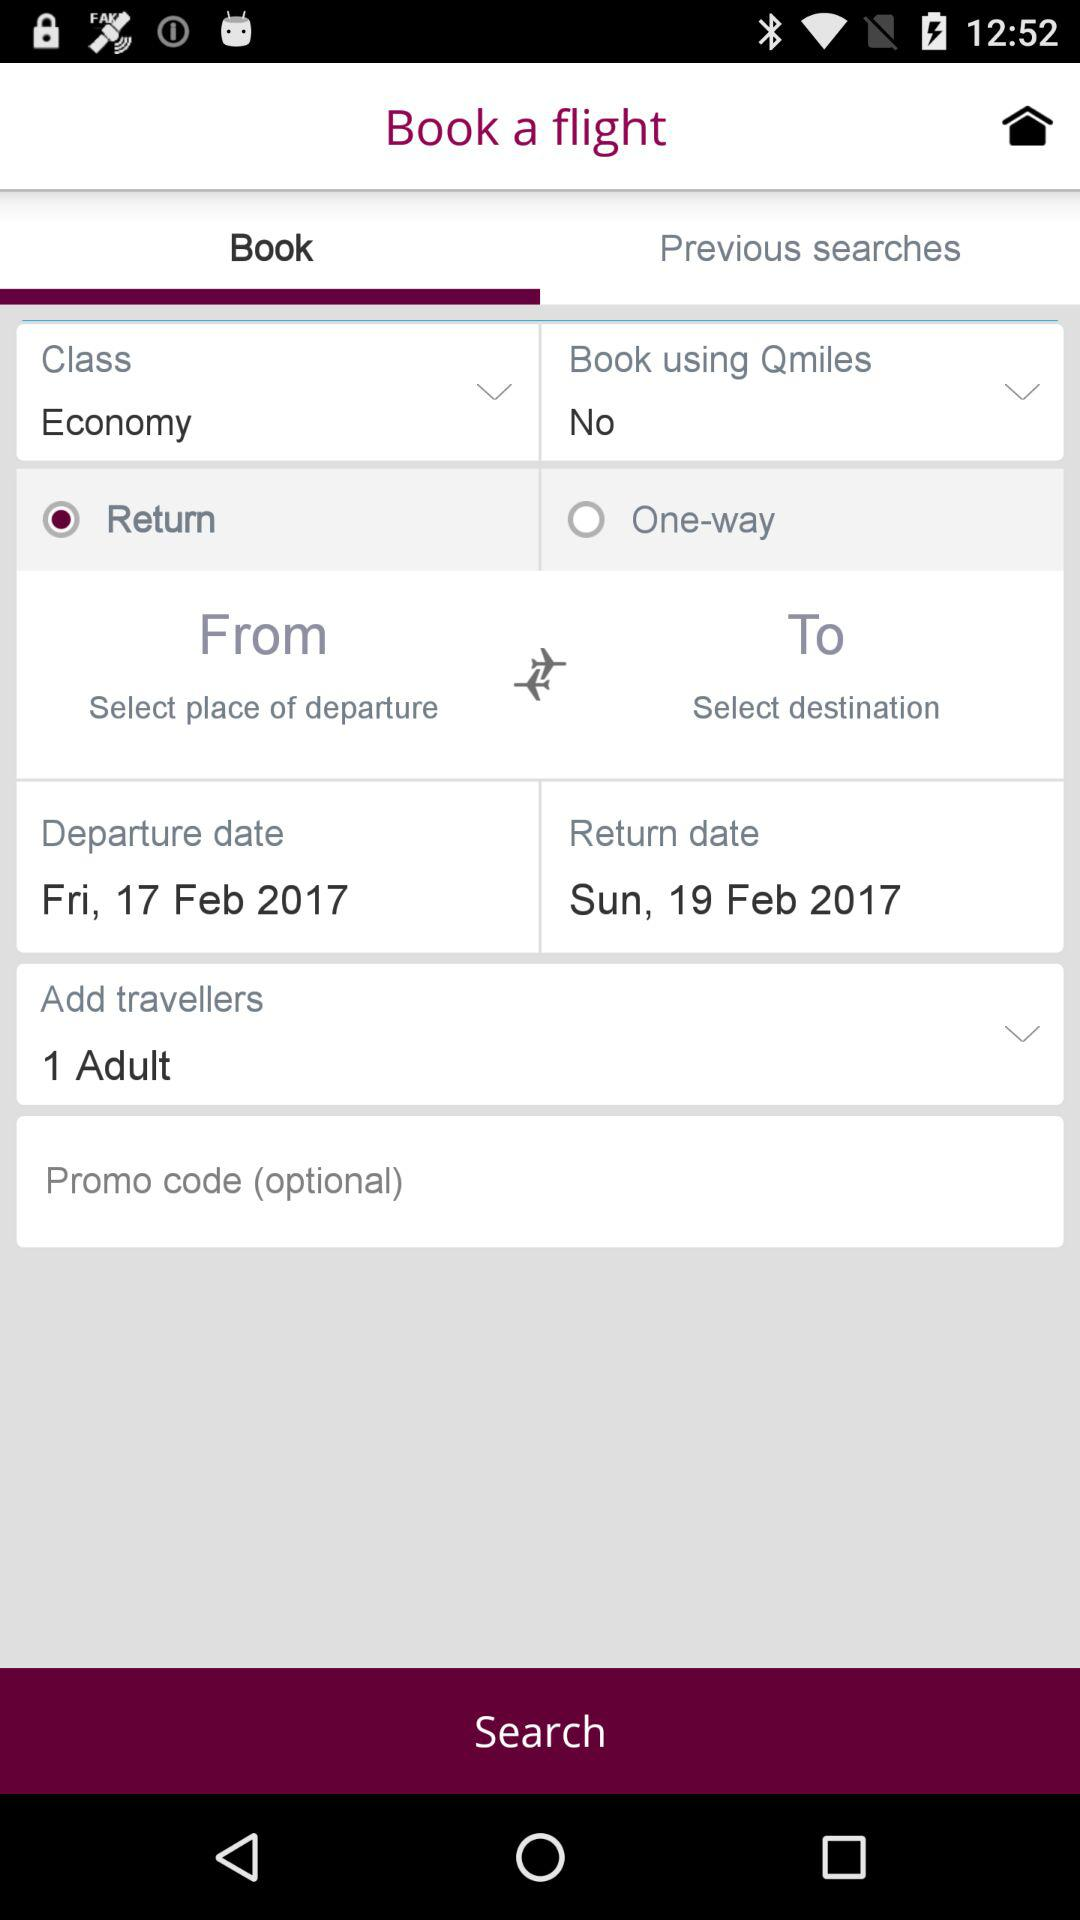What is the return date? The return date is Sunday, February 19, 2017. 